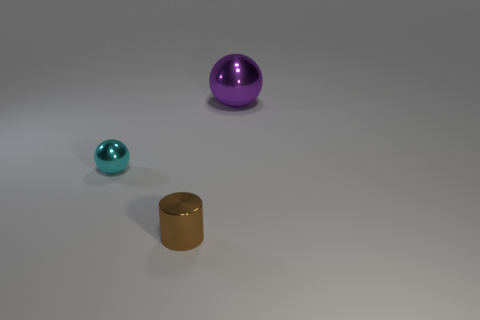The small shiny object that is the same shape as the big purple thing is what color?
Your answer should be very brief. Cyan. Are there the same number of metal cylinders right of the large metal sphere and big shiny spheres?
Provide a succinct answer. No. How many cylinders are either large objects or big brown objects?
Offer a terse response. 0. There is a small object that is made of the same material as the brown cylinder; what is its color?
Provide a succinct answer. Cyan. Do the tiny brown cylinder and the ball on the right side of the tiny cyan object have the same material?
Provide a short and direct response. Yes. How many things are big purple metal balls or big blue metallic things?
Offer a terse response. 1. Is there another cyan metallic thing of the same shape as the big thing?
Your answer should be very brief. Yes. What number of metal objects are right of the tiny brown shiny cylinder?
Your answer should be very brief. 1. What material is the brown cylinder that is right of the sphere that is in front of the big shiny ball made of?
Your response must be concise. Metal. There is a cyan thing that is the same size as the cylinder; what is it made of?
Provide a short and direct response. Metal. 